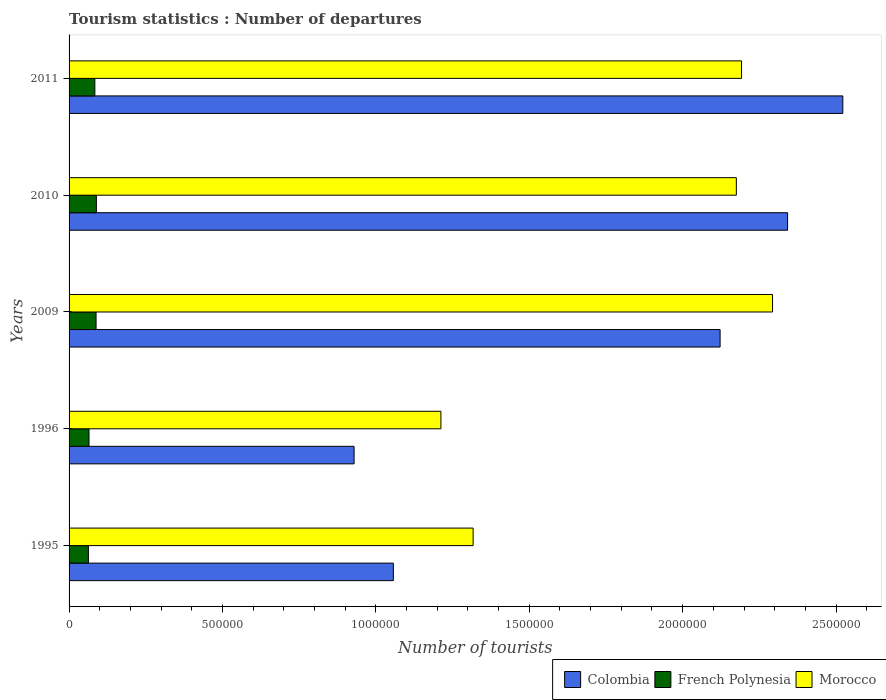Are the number of bars on each tick of the Y-axis equal?
Give a very brief answer. Yes. How many bars are there on the 4th tick from the top?
Give a very brief answer. 3. How many bars are there on the 3rd tick from the bottom?
Give a very brief answer. 3. What is the label of the 1st group of bars from the top?
Keep it short and to the point. 2011. In how many cases, is the number of bars for a given year not equal to the number of legend labels?
Ensure brevity in your answer.  0. What is the number of tourist departures in Colombia in 1996?
Offer a terse response. 9.29e+05. Across all years, what is the maximum number of tourist departures in French Polynesia?
Offer a terse response. 8.90e+04. Across all years, what is the minimum number of tourist departures in Colombia?
Give a very brief answer. 9.29e+05. In which year was the number of tourist departures in French Polynesia maximum?
Your response must be concise. 2010. In which year was the number of tourist departures in French Polynesia minimum?
Provide a short and direct response. 1995. What is the total number of tourist departures in Morocco in the graph?
Offer a terse response. 9.19e+06. What is the difference between the number of tourist departures in Morocco in 1995 and that in 2011?
Your answer should be very brief. -8.75e+05. What is the difference between the number of tourist departures in Colombia in 2010 and the number of tourist departures in French Polynesia in 1995?
Give a very brief answer. 2.28e+06. What is the average number of tourist departures in Morocco per year?
Your response must be concise. 1.84e+06. What is the ratio of the number of tourist departures in French Polynesia in 2009 to that in 2010?
Your answer should be very brief. 0.99. Is the difference between the number of tourist departures in Colombia in 1996 and 2010 greater than the difference between the number of tourist departures in Morocco in 1996 and 2010?
Offer a very short reply. No. What is the difference between the highest and the second highest number of tourist departures in Morocco?
Provide a succinct answer. 1.01e+05. What is the difference between the highest and the lowest number of tourist departures in Colombia?
Offer a terse response. 1.59e+06. In how many years, is the number of tourist departures in Morocco greater than the average number of tourist departures in Morocco taken over all years?
Provide a short and direct response. 3. Is the sum of the number of tourist departures in Colombia in 1996 and 2011 greater than the maximum number of tourist departures in French Polynesia across all years?
Provide a short and direct response. Yes. What does the 2nd bar from the top in 2011 represents?
Provide a succinct answer. French Polynesia. What does the 3rd bar from the bottom in 1995 represents?
Keep it short and to the point. Morocco. How many bars are there?
Keep it short and to the point. 15. How many years are there in the graph?
Offer a terse response. 5. Does the graph contain grids?
Your response must be concise. No. What is the title of the graph?
Your answer should be compact. Tourism statistics : Number of departures. What is the label or title of the X-axis?
Ensure brevity in your answer.  Number of tourists. What is the Number of tourists of Colombia in 1995?
Give a very brief answer. 1.06e+06. What is the Number of tourists of French Polynesia in 1995?
Give a very brief answer. 6.30e+04. What is the Number of tourists in Morocco in 1995?
Your answer should be compact. 1.32e+06. What is the Number of tourists of Colombia in 1996?
Provide a short and direct response. 9.29e+05. What is the Number of tourists in French Polynesia in 1996?
Your response must be concise. 6.50e+04. What is the Number of tourists of Morocco in 1996?
Give a very brief answer. 1.21e+06. What is the Number of tourists of Colombia in 2009?
Provide a short and direct response. 2.12e+06. What is the Number of tourists in French Polynesia in 2009?
Offer a very short reply. 8.80e+04. What is the Number of tourists in Morocco in 2009?
Your answer should be very brief. 2.29e+06. What is the Number of tourists of Colombia in 2010?
Your answer should be compact. 2.34e+06. What is the Number of tourists of French Polynesia in 2010?
Provide a short and direct response. 8.90e+04. What is the Number of tourists of Morocco in 2010?
Give a very brief answer. 2.18e+06. What is the Number of tourists of Colombia in 2011?
Provide a short and direct response. 2.52e+06. What is the Number of tourists of French Polynesia in 2011?
Your answer should be very brief. 8.40e+04. What is the Number of tourists of Morocco in 2011?
Your response must be concise. 2.19e+06. Across all years, what is the maximum Number of tourists in Colombia?
Your answer should be compact. 2.52e+06. Across all years, what is the maximum Number of tourists in French Polynesia?
Make the answer very short. 8.90e+04. Across all years, what is the maximum Number of tourists in Morocco?
Keep it short and to the point. 2.29e+06. Across all years, what is the minimum Number of tourists of Colombia?
Your response must be concise. 9.29e+05. Across all years, what is the minimum Number of tourists of French Polynesia?
Your answer should be very brief. 6.30e+04. Across all years, what is the minimum Number of tourists of Morocco?
Your response must be concise. 1.21e+06. What is the total Number of tourists of Colombia in the graph?
Give a very brief answer. 8.97e+06. What is the total Number of tourists of French Polynesia in the graph?
Make the answer very short. 3.89e+05. What is the total Number of tourists of Morocco in the graph?
Offer a very short reply. 9.19e+06. What is the difference between the Number of tourists in Colombia in 1995 and that in 1996?
Your answer should be compact. 1.28e+05. What is the difference between the Number of tourists in French Polynesia in 1995 and that in 1996?
Offer a very short reply. -2000. What is the difference between the Number of tourists of Morocco in 1995 and that in 1996?
Give a very brief answer. 1.05e+05. What is the difference between the Number of tourists of Colombia in 1995 and that in 2009?
Your response must be concise. -1.06e+06. What is the difference between the Number of tourists in French Polynesia in 1995 and that in 2009?
Provide a succinct answer. -2.50e+04. What is the difference between the Number of tourists in Morocco in 1995 and that in 2009?
Provide a succinct answer. -9.76e+05. What is the difference between the Number of tourists of Colombia in 1995 and that in 2010?
Keep it short and to the point. -1.28e+06. What is the difference between the Number of tourists of French Polynesia in 1995 and that in 2010?
Provide a short and direct response. -2.60e+04. What is the difference between the Number of tourists of Morocco in 1995 and that in 2010?
Keep it short and to the point. -8.58e+05. What is the difference between the Number of tourists of Colombia in 1995 and that in 2011?
Keep it short and to the point. -1.46e+06. What is the difference between the Number of tourists of French Polynesia in 1995 and that in 2011?
Provide a short and direct response. -2.10e+04. What is the difference between the Number of tourists of Morocco in 1995 and that in 2011?
Provide a succinct answer. -8.75e+05. What is the difference between the Number of tourists in Colombia in 1996 and that in 2009?
Your response must be concise. -1.19e+06. What is the difference between the Number of tourists in French Polynesia in 1996 and that in 2009?
Offer a very short reply. -2.30e+04. What is the difference between the Number of tourists of Morocco in 1996 and that in 2009?
Your answer should be very brief. -1.08e+06. What is the difference between the Number of tourists in Colombia in 1996 and that in 2010?
Your answer should be very brief. -1.41e+06. What is the difference between the Number of tourists in French Polynesia in 1996 and that in 2010?
Your answer should be compact. -2.40e+04. What is the difference between the Number of tourists of Morocco in 1996 and that in 2010?
Provide a succinct answer. -9.63e+05. What is the difference between the Number of tourists of Colombia in 1996 and that in 2011?
Offer a very short reply. -1.59e+06. What is the difference between the Number of tourists of French Polynesia in 1996 and that in 2011?
Your answer should be compact. -1.90e+04. What is the difference between the Number of tourists of Morocco in 1996 and that in 2011?
Offer a terse response. -9.80e+05. What is the difference between the Number of tourists in French Polynesia in 2009 and that in 2010?
Your answer should be very brief. -1000. What is the difference between the Number of tourists in Morocco in 2009 and that in 2010?
Keep it short and to the point. 1.18e+05. What is the difference between the Number of tourists in Colombia in 2009 and that in 2011?
Make the answer very short. -4.00e+05. What is the difference between the Number of tourists of French Polynesia in 2009 and that in 2011?
Offer a very short reply. 4000. What is the difference between the Number of tourists of Morocco in 2009 and that in 2011?
Make the answer very short. 1.01e+05. What is the difference between the Number of tourists in Colombia in 2010 and that in 2011?
Offer a very short reply. -1.80e+05. What is the difference between the Number of tourists in Morocco in 2010 and that in 2011?
Your response must be concise. -1.70e+04. What is the difference between the Number of tourists in Colombia in 1995 and the Number of tourists in French Polynesia in 1996?
Keep it short and to the point. 9.92e+05. What is the difference between the Number of tourists in Colombia in 1995 and the Number of tourists in Morocco in 1996?
Provide a succinct answer. -1.55e+05. What is the difference between the Number of tourists of French Polynesia in 1995 and the Number of tourists of Morocco in 1996?
Ensure brevity in your answer.  -1.15e+06. What is the difference between the Number of tourists of Colombia in 1995 and the Number of tourists of French Polynesia in 2009?
Keep it short and to the point. 9.69e+05. What is the difference between the Number of tourists of Colombia in 1995 and the Number of tourists of Morocco in 2009?
Provide a short and direct response. -1.24e+06. What is the difference between the Number of tourists of French Polynesia in 1995 and the Number of tourists of Morocco in 2009?
Provide a short and direct response. -2.23e+06. What is the difference between the Number of tourists in Colombia in 1995 and the Number of tourists in French Polynesia in 2010?
Give a very brief answer. 9.68e+05. What is the difference between the Number of tourists of Colombia in 1995 and the Number of tourists of Morocco in 2010?
Your answer should be very brief. -1.12e+06. What is the difference between the Number of tourists of French Polynesia in 1995 and the Number of tourists of Morocco in 2010?
Provide a succinct answer. -2.11e+06. What is the difference between the Number of tourists in Colombia in 1995 and the Number of tourists in French Polynesia in 2011?
Your response must be concise. 9.73e+05. What is the difference between the Number of tourists in Colombia in 1995 and the Number of tourists in Morocco in 2011?
Offer a very short reply. -1.14e+06. What is the difference between the Number of tourists in French Polynesia in 1995 and the Number of tourists in Morocco in 2011?
Ensure brevity in your answer.  -2.13e+06. What is the difference between the Number of tourists of Colombia in 1996 and the Number of tourists of French Polynesia in 2009?
Your answer should be compact. 8.41e+05. What is the difference between the Number of tourists of Colombia in 1996 and the Number of tourists of Morocco in 2009?
Give a very brief answer. -1.36e+06. What is the difference between the Number of tourists in French Polynesia in 1996 and the Number of tourists in Morocco in 2009?
Give a very brief answer. -2.23e+06. What is the difference between the Number of tourists of Colombia in 1996 and the Number of tourists of French Polynesia in 2010?
Make the answer very short. 8.40e+05. What is the difference between the Number of tourists in Colombia in 1996 and the Number of tourists in Morocco in 2010?
Offer a terse response. -1.25e+06. What is the difference between the Number of tourists of French Polynesia in 1996 and the Number of tourists of Morocco in 2010?
Keep it short and to the point. -2.11e+06. What is the difference between the Number of tourists of Colombia in 1996 and the Number of tourists of French Polynesia in 2011?
Offer a very short reply. 8.45e+05. What is the difference between the Number of tourists in Colombia in 1996 and the Number of tourists in Morocco in 2011?
Give a very brief answer. -1.26e+06. What is the difference between the Number of tourists in French Polynesia in 1996 and the Number of tourists in Morocco in 2011?
Ensure brevity in your answer.  -2.13e+06. What is the difference between the Number of tourists of Colombia in 2009 and the Number of tourists of French Polynesia in 2010?
Provide a succinct answer. 2.03e+06. What is the difference between the Number of tourists of Colombia in 2009 and the Number of tourists of Morocco in 2010?
Provide a succinct answer. -5.30e+04. What is the difference between the Number of tourists of French Polynesia in 2009 and the Number of tourists of Morocco in 2010?
Keep it short and to the point. -2.09e+06. What is the difference between the Number of tourists in Colombia in 2009 and the Number of tourists in French Polynesia in 2011?
Your answer should be compact. 2.04e+06. What is the difference between the Number of tourists of Colombia in 2009 and the Number of tourists of Morocco in 2011?
Give a very brief answer. -7.00e+04. What is the difference between the Number of tourists in French Polynesia in 2009 and the Number of tourists in Morocco in 2011?
Offer a very short reply. -2.10e+06. What is the difference between the Number of tourists of Colombia in 2010 and the Number of tourists of French Polynesia in 2011?
Give a very brief answer. 2.26e+06. What is the difference between the Number of tourists in French Polynesia in 2010 and the Number of tourists in Morocco in 2011?
Your answer should be very brief. -2.10e+06. What is the average Number of tourists of Colombia per year?
Ensure brevity in your answer.  1.79e+06. What is the average Number of tourists in French Polynesia per year?
Your response must be concise. 7.78e+04. What is the average Number of tourists in Morocco per year?
Make the answer very short. 1.84e+06. In the year 1995, what is the difference between the Number of tourists in Colombia and Number of tourists in French Polynesia?
Ensure brevity in your answer.  9.94e+05. In the year 1995, what is the difference between the Number of tourists in Colombia and Number of tourists in Morocco?
Your answer should be very brief. -2.60e+05. In the year 1995, what is the difference between the Number of tourists in French Polynesia and Number of tourists in Morocco?
Your answer should be very brief. -1.25e+06. In the year 1996, what is the difference between the Number of tourists in Colombia and Number of tourists in French Polynesia?
Provide a succinct answer. 8.64e+05. In the year 1996, what is the difference between the Number of tourists of Colombia and Number of tourists of Morocco?
Your response must be concise. -2.83e+05. In the year 1996, what is the difference between the Number of tourists of French Polynesia and Number of tourists of Morocco?
Keep it short and to the point. -1.15e+06. In the year 2009, what is the difference between the Number of tourists of Colombia and Number of tourists of French Polynesia?
Ensure brevity in your answer.  2.03e+06. In the year 2009, what is the difference between the Number of tourists in Colombia and Number of tourists in Morocco?
Ensure brevity in your answer.  -1.71e+05. In the year 2009, what is the difference between the Number of tourists in French Polynesia and Number of tourists in Morocco?
Offer a terse response. -2.20e+06. In the year 2010, what is the difference between the Number of tourists of Colombia and Number of tourists of French Polynesia?
Your answer should be compact. 2.25e+06. In the year 2010, what is the difference between the Number of tourists of Colombia and Number of tourists of Morocco?
Your answer should be compact. 1.67e+05. In the year 2010, what is the difference between the Number of tourists in French Polynesia and Number of tourists in Morocco?
Provide a short and direct response. -2.09e+06. In the year 2011, what is the difference between the Number of tourists in Colombia and Number of tourists in French Polynesia?
Ensure brevity in your answer.  2.44e+06. In the year 2011, what is the difference between the Number of tourists of Colombia and Number of tourists of Morocco?
Your response must be concise. 3.30e+05. In the year 2011, what is the difference between the Number of tourists of French Polynesia and Number of tourists of Morocco?
Offer a very short reply. -2.11e+06. What is the ratio of the Number of tourists of Colombia in 1995 to that in 1996?
Your answer should be very brief. 1.14. What is the ratio of the Number of tourists in French Polynesia in 1995 to that in 1996?
Give a very brief answer. 0.97. What is the ratio of the Number of tourists in Morocco in 1995 to that in 1996?
Ensure brevity in your answer.  1.09. What is the ratio of the Number of tourists of Colombia in 1995 to that in 2009?
Provide a short and direct response. 0.5. What is the ratio of the Number of tourists in French Polynesia in 1995 to that in 2009?
Provide a short and direct response. 0.72. What is the ratio of the Number of tourists of Morocco in 1995 to that in 2009?
Provide a short and direct response. 0.57. What is the ratio of the Number of tourists of Colombia in 1995 to that in 2010?
Give a very brief answer. 0.45. What is the ratio of the Number of tourists in French Polynesia in 1995 to that in 2010?
Offer a very short reply. 0.71. What is the ratio of the Number of tourists in Morocco in 1995 to that in 2010?
Give a very brief answer. 0.61. What is the ratio of the Number of tourists of Colombia in 1995 to that in 2011?
Keep it short and to the point. 0.42. What is the ratio of the Number of tourists of French Polynesia in 1995 to that in 2011?
Ensure brevity in your answer.  0.75. What is the ratio of the Number of tourists in Morocco in 1995 to that in 2011?
Ensure brevity in your answer.  0.6. What is the ratio of the Number of tourists of Colombia in 1996 to that in 2009?
Offer a terse response. 0.44. What is the ratio of the Number of tourists in French Polynesia in 1996 to that in 2009?
Give a very brief answer. 0.74. What is the ratio of the Number of tourists in Morocco in 1996 to that in 2009?
Ensure brevity in your answer.  0.53. What is the ratio of the Number of tourists in Colombia in 1996 to that in 2010?
Your response must be concise. 0.4. What is the ratio of the Number of tourists in French Polynesia in 1996 to that in 2010?
Offer a very short reply. 0.73. What is the ratio of the Number of tourists in Morocco in 1996 to that in 2010?
Give a very brief answer. 0.56. What is the ratio of the Number of tourists in Colombia in 1996 to that in 2011?
Ensure brevity in your answer.  0.37. What is the ratio of the Number of tourists of French Polynesia in 1996 to that in 2011?
Your answer should be very brief. 0.77. What is the ratio of the Number of tourists of Morocco in 1996 to that in 2011?
Your answer should be very brief. 0.55. What is the ratio of the Number of tourists of Colombia in 2009 to that in 2010?
Make the answer very short. 0.91. What is the ratio of the Number of tourists of Morocco in 2009 to that in 2010?
Your answer should be very brief. 1.05. What is the ratio of the Number of tourists of Colombia in 2009 to that in 2011?
Provide a succinct answer. 0.84. What is the ratio of the Number of tourists of French Polynesia in 2009 to that in 2011?
Make the answer very short. 1.05. What is the ratio of the Number of tourists in Morocco in 2009 to that in 2011?
Give a very brief answer. 1.05. What is the ratio of the Number of tourists of Colombia in 2010 to that in 2011?
Make the answer very short. 0.93. What is the ratio of the Number of tourists in French Polynesia in 2010 to that in 2011?
Your response must be concise. 1.06. What is the difference between the highest and the second highest Number of tourists of Colombia?
Your answer should be compact. 1.80e+05. What is the difference between the highest and the second highest Number of tourists in French Polynesia?
Your answer should be compact. 1000. What is the difference between the highest and the second highest Number of tourists of Morocco?
Give a very brief answer. 1.01e+05. What is the difference between the highest and the lowest Number of tourists in Colombia?
Offer a terse response. 1.59e+06. What is the difference between the highest and the lowest Number of tourists of French Polynesia?
Provide a succinct answer. 2.60e+04. What is the difference between the highest and the lowest Number of tourists in Morocco?
Your answer should be compact. 1.08e+06. 